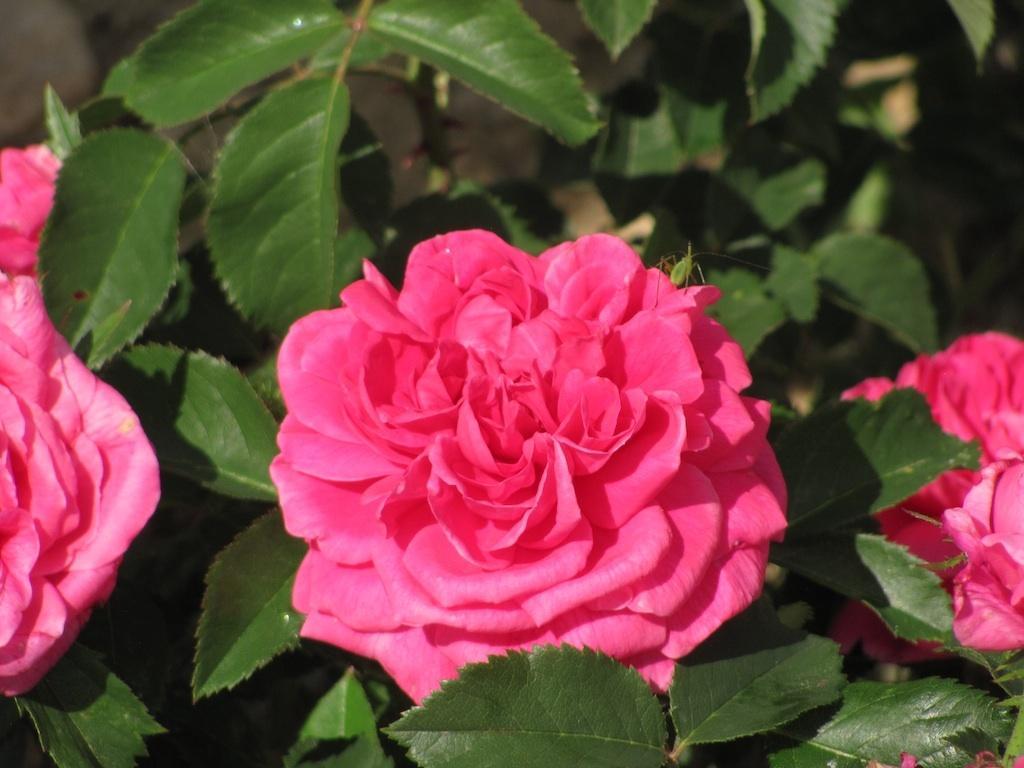Describe this image in one or two sentences. In this image there are some rose flowers and plants. 